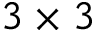Convert formula to latex. <formula><loc_0><loc_0><loc_500><loc_500>3 \times 3</formula> 